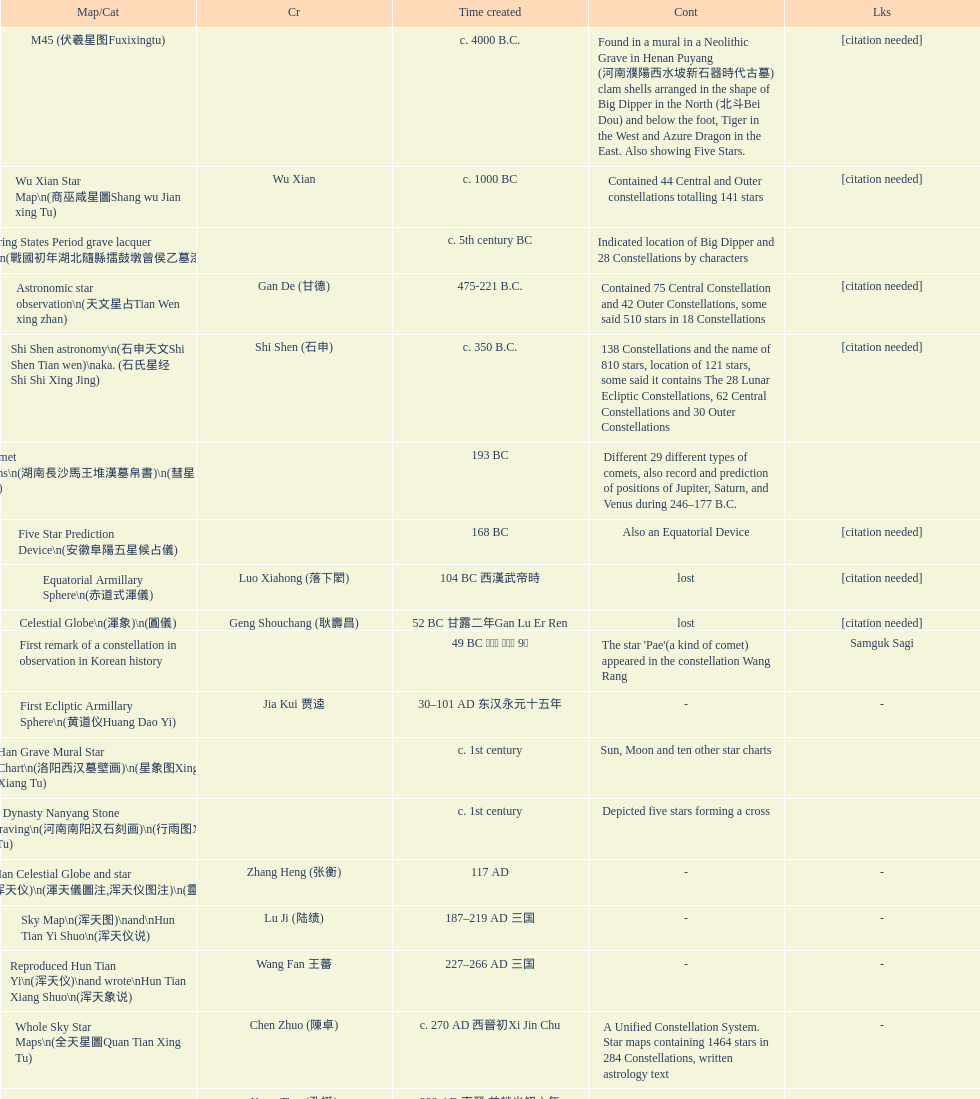Name three items created not long after the equatorial armillary sphere. Celestial Globe (渾象) (圓儀), First remark of a constellation in observation in Korean history, First Ecliptic Armillary Sphere (黄道仪Huang Dao Yi). 